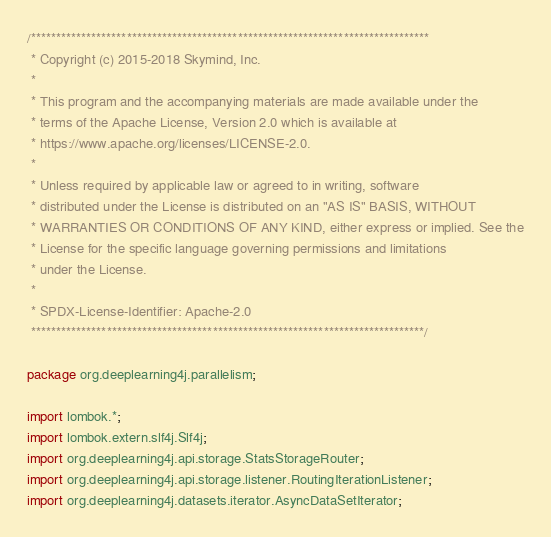Convert code to text. <code><loc_0><loc_0><loc_500><loc_500><_Java_>/*******************************************************************************
 * Copyright (c) 2015-2018 Skymind, Inc.
 *
 * This program and the accompanying materials are made available under the
 * terms of the Apache License, Version 2.0 which is available at
 * https://www.apache.org/licenses/LICENSE-2.0.
 *
 * Unless required by applicable law or agreed to in writing, software
 * distributed under the License is distributed on an "AS IS" BASIS, WITHOUT
 * WARRANTIES OR CONDITIONS OF ANY KIND, either express or implied. See the
 * License for the specific language governing permissions and limitations
 * under the License.
 *
 * SPDX-License-Identifier: Apache-2.0
 ******************************************************************************/

package org.deeplearning4j.parallelism;

import lombok.*;
import lombok.extern.slf4j.Slf4j;
import org.deeplearning4j.api.storage.StatsStorageRouter;
import org.deeplearning4j.api.storage.listener.RoutingIterationListener;
import org.deeplearning4j.datasets.iterator.AsyncDataSetIterator;</code> 